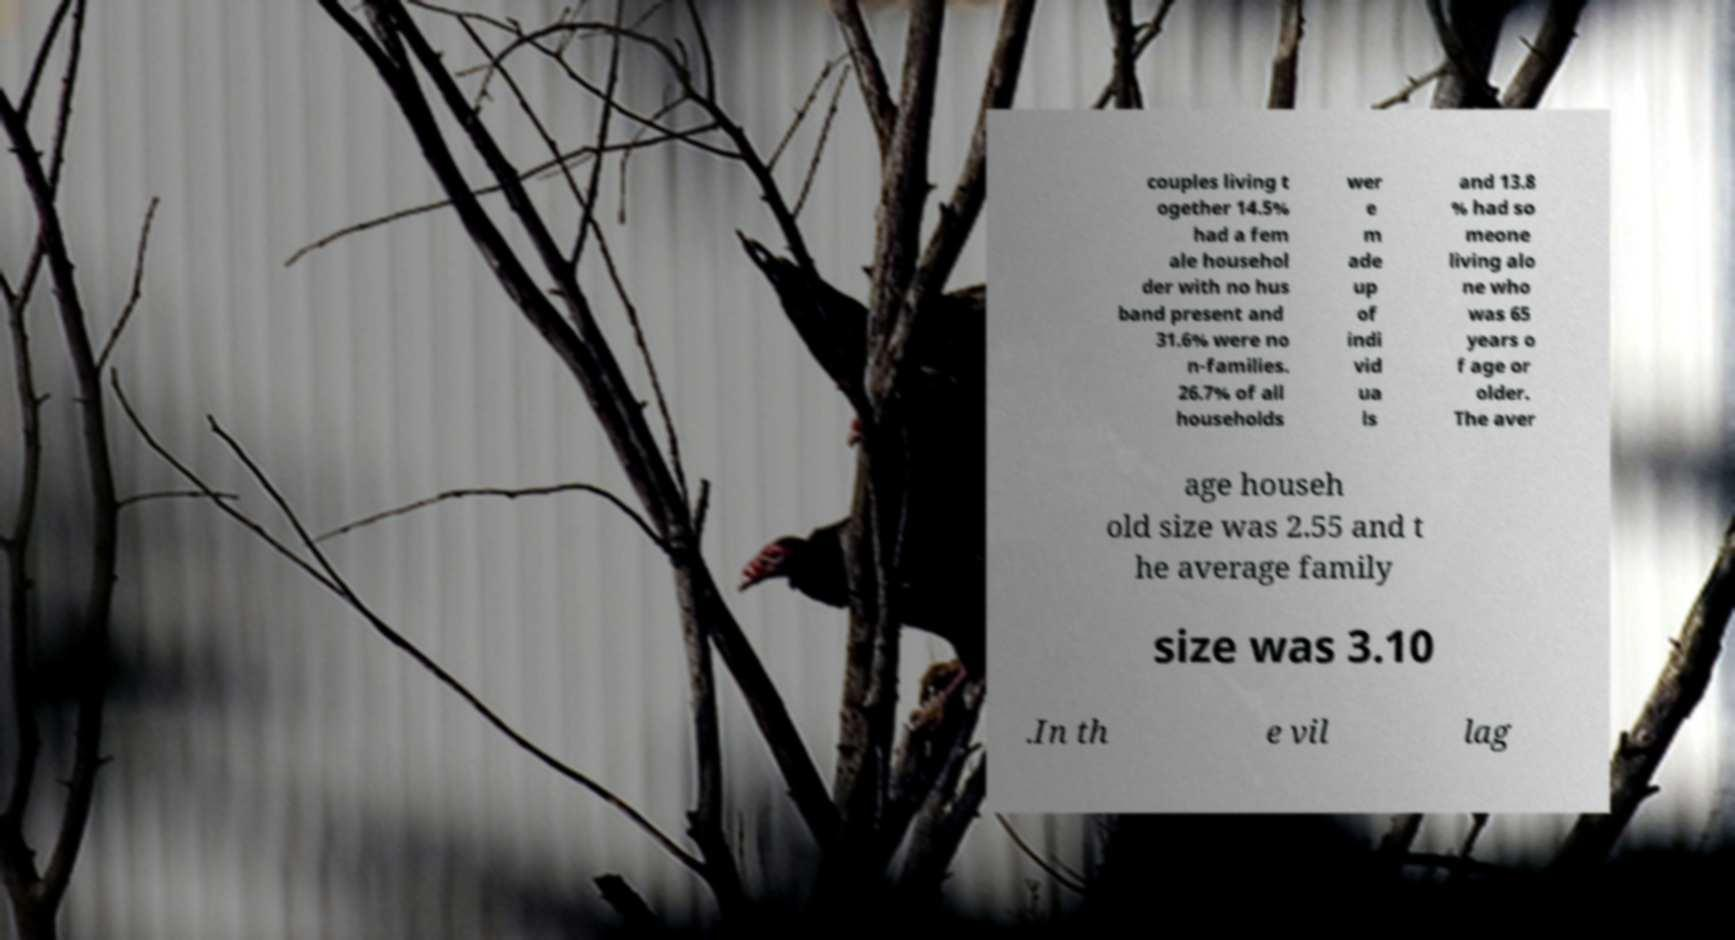Could you assist in decoding the text presented in this image and type it out clearly? couples living t ogether 14.5% had a fem ale househol der with no hus band present and 31.6% were no n-families. 26.7% of all households wer e m ade up of indi vid ua ls and 13.8 % had so meone living alo ne who was 65 years o f age or older. The aver age househ old size was 2.55 and t he average family size was 3.10 .In th e vil lag 